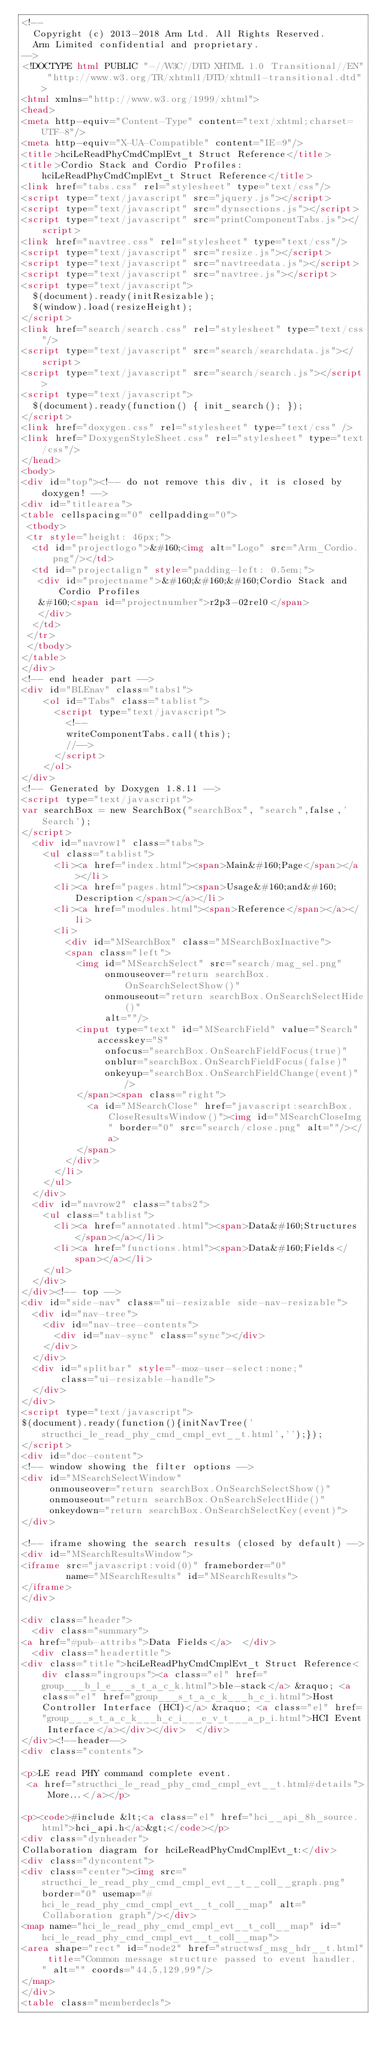Convert code to text. <code><loc_0><loc_0><loc_500><loc_500><_HTML_><!--
  Copyright (c) 2013-2018 Arm Ltd. All Rights Reserved.
  Arm Limited confidential and proprietary.
-->
<!DOCTYPE html PUBLIC "-//W3C//DTD XHTML 1.0 Transitional//EN" "http://www.w3.org/TR/xhtml1/DTD/xhtml1-transitional.dtd">
<html xmlns="http://www.w3.org/1999/xhtml">
<head>
<meta http-equiv="Content-Type" content="text/xhtml;charset=UTF-8"/>
<meta http-equiv="X-UA-Compatible" content="IE=9"/>
<title>hciLeReadPhyCmdCmplEvt_t Struct Reference</title>
<title>Cordio Stack and Cordio Profiles: hciLeReadPhyCmdCmplEvt_t Struct Reference</title>
<link href="tabs.css" rel="stylesheet" type="text/css"/>
<script type="text/javascript" src="jquery.js"></script>
<script type="text/javascript" src="dynsections.js"></script>
<script type="text/javascript" src="printComponentTabs.js"></script>
<link href="navtree.css" rel="stylesheet" type="text/css"/>
<script type="text/javascript" src="resize.js"></script>
<script type="text/javascript" src="navtreedata.js"></script>
<script type="text/javascript" src="navtree.js"></script>
<script type="text/javascript">
  $(document).ready(initResizable);
  $(window).load(resizeHeight);
</script>
<link href="search/search.css" rel="stylesheet" type="text/css"/>
<script type="text/javascript" src="search/searchdata.js"></script>
<script type="text/javascript" src="search/search.js"></script>
<script type="text/javascript">
  $(document).ready(function() { init_search(); });
</script>
<link href="doxygen.css" rel="stylesheet" type="text/css" />
<link href="DoxygenStyleSheet.css" rel="stylesheet" type="text/css"/>
</head>
<body>
<div id="top"><!-- do not remove this div, it is closed by doxygen! -->
<div id="titlearea">
<table cellspacing="0" cellpadding="0">
 <tbody>
 <tr style="height: 46px;">
  <td id="projectlogo">&#160;<img alt="Logo" src="Arm_Cordio.png"/></td>
  <td id="projectalign" style="padding-left: 0.5em;">
   <div id="projectname">&#160;&#160;&#160;Cordio Stack and Cordio Profiles
   &#160;<span id="projectnumber">r2p3-02rel0</span>
   </div>
  </td>
 </tr>
 </tbody>
</table>
</div>
<!-- end header part -->
<div id="BLEnav" class="tabs1">
    <ol id="Tabs" class="tablist">
      <script type="text/javascript">
        <!--
        writeComponentTabs.call(this);
        //-->
      </script>
    </ol>
</div>
<!-- Generated by Doxygen 1.8.11 -->
<script type="text/javascript">
var searchBox = new SearchBox("searchBox", "search",false,'Search');
</script>
  <div id="navrow1" class="tabs">
    <ul class="tablist">
      <li><a href="index.html"><span>Main&#160;Page</span></a></li>
      <li><a href="pages.html"><span>Usage&#160;and&#160;Description</span></a></li>
      <li><a href="modules.html"><span>Reference</span></a></li>
      <li>
        <div id="MSearchBox" class="MSearchBoxInactive">
        <span class="left">
          <img id="MSearchSelect" src="search/mag_sel.png"
               onmouseover="return searchBox.OnSearchSelectShow()"
               onmouseout="return searchBox.OnSearchSelectHide()"
               alt=""/>
          <input type="text" id="MSearchField" value="Search" accesskey="S"
               onfocus="searchBox.OnSearchFieldFocus(true)" 
               onblur="searchBox.OnSearchFieldFocus(false)" 
               onkeyup="searchBox.OnSearchFieldChange(event)"/>
          </span><span class="right">
            <a id="MSearchClose" href="javascript:searchBox.CloseResultsWindow()"><img id="MSearchCloseImg" border="0" src="search/close.png" alt=""/></a>
          </span>
        </div>
      </li>
    </ul>
  </div>
  <div id="navrow2" class="tabs2">
    <ul class="tablist">
      <li><a href="annotated.html"><span>Data&#160;Structures</span></a></li>
      <li><a href="functions.html"><span>Data&#160;Fields</span></a></li>
    </ul>
  </div>
</div><!-- top -->
<div id="side-nav" class="ui-resizable side-nav-resizable">
  <div id="nav-tree">
    <div id="nav-tree-contents">
      <div id="nav-sync" class="sync"></div>
    </div>
  </div>
  <div id="splitbar" style="-moz-user-select:none;" 
       class="ui-resizable-handle">
  </div>
</div>
<script type="text/javascript">
$(document).ready(function(){initNavTree('structhci_le_read_phy_cmd_cmpl_evt__t.html','');});
</script>
<div id="doc-content">
<!-- window showing the filter options -->
<div id="MSearchSelectWindow"
     onmouseover="return searchBox.OnSearchSelectShow()"
     onmouseout="return searchBox.OnSearchSelectHide()"
     onkeydown="return searchBox.OnSearchSelectKey(event)">
</div>

<!-- iframe showing the search results (closed by default) -->
<div id="MSearchResultsWindow">
<iframe src="javascript:void(0)" frameborder="0" 
        name="MSearchResults" id="MSearchResults">
</iframe>
</div>

<div class="header">
  <div class="summary">
<a href="#pub-attribs">Data Fields</a>  </div>
  <div class="headertitle">
<div class="title">hciLeReadPhyCmdCmplEvt_t Struct Reference<div class="ingroups"><a class="el" href="group___b_l_e___s_t_a_c_k.html">ble-stack</a> &raquo; <a class="el" href="group___s_t_a_c_k___h_c_i.html">Host Controller Interface (HCI)</a> &raquo; <a class="el" href="group___s_t_a_c_k___h_c_i___e_v_t___a_p_i.html">HCI Event Interface</a></div></div>  </div>
</div><!--header-->
<div class="contents">

<p>LE read PHY command complete event.  
 <a href="structhci_le_read_phy_cmd_cmpl_evt__t.html#details">More...</a></p>

<p><code>#include &lt;<a class="el" href="hci__api_8h_source.html">hci_api.h</a>&gt;</code></p>
<div class="dynheader">
Collaboration diagram for hciLeReadPhyCmdCmplEvt_t:</div>
<div class="dyncontent">
<div class="center"><img src="structhci_le_read_phy_cmd_cmpl_evt__t__coll__graph.png" border="0" usemap="#hci_le_read_phy_cmd_cmpl_evt__t_coll__map" alt="Collaboration graph"/></div>
<map name="hci_le_read_phy_cmd_cmpl_evt__t_coll__map" id="hci_le_read_phy_cmd_cmpl_evt__t_coll__map">
<area shape="rect" id="node2" href="structwsf_msg_hdr__t.html" title="Common message structure passed to event handler. " alt="" coords="44,5,129,99"/>
</map>
</div>
<table class="memberdecls"></code> 